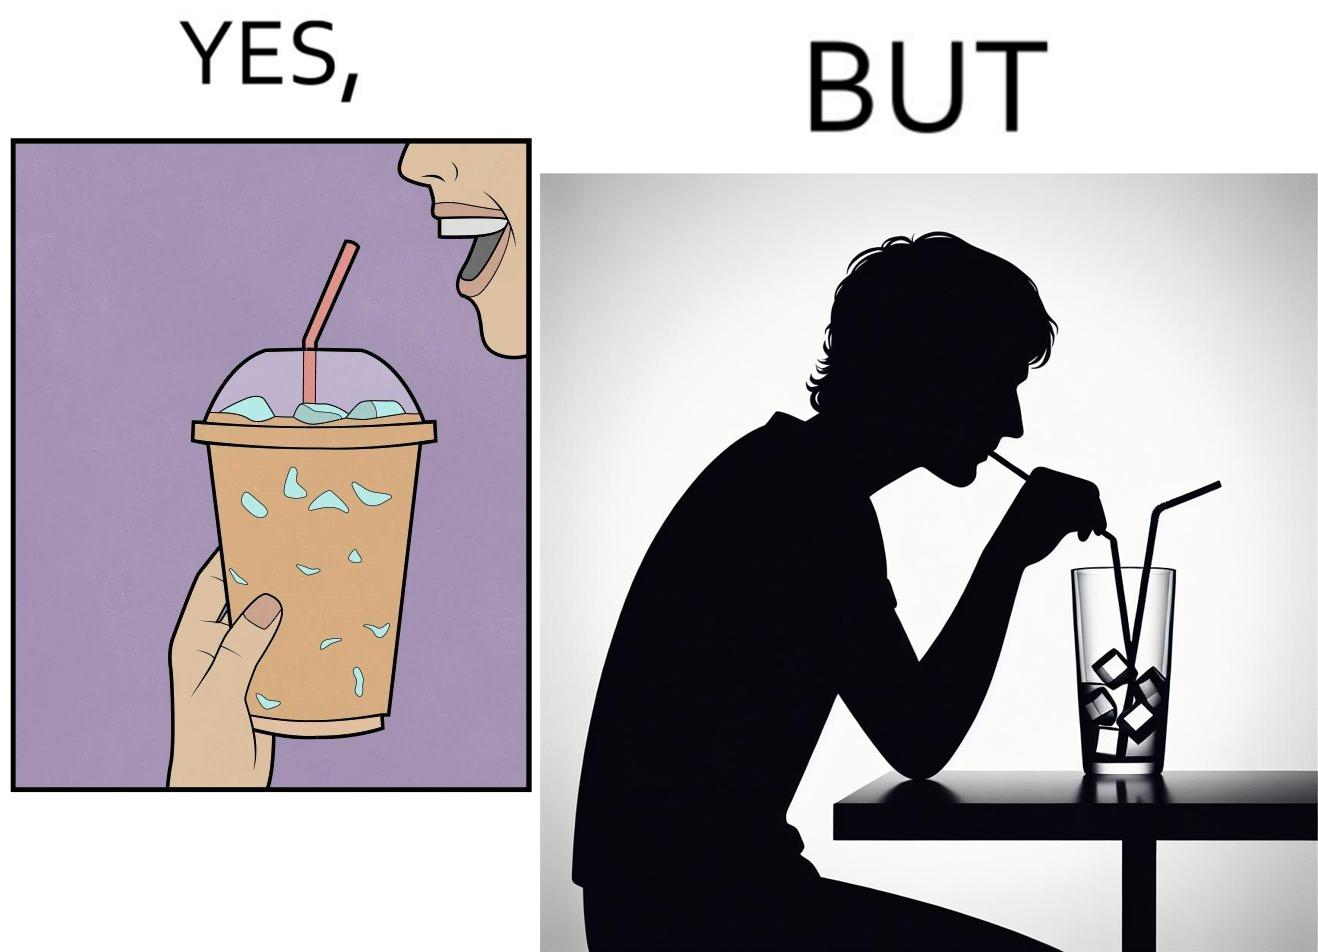Why is this image considered satirical? The image is funny, as the drink seems to be full to begin with, while most of the volume of the drink is occupied by the ice cubes. 